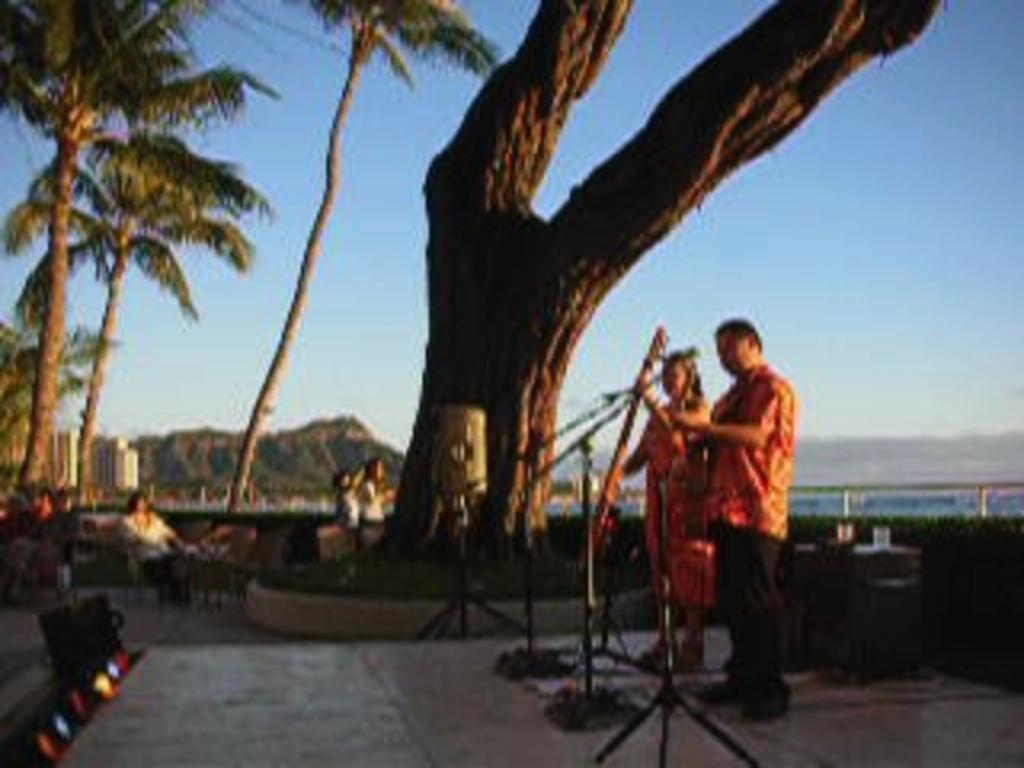How many people are standing on the right side of the image? There are two people standing people on the right side of the image. What can be seen near the standing people? There are mics placed on stands near the standing people. What is happening in the background of the image? In the background, there are people sitting, and trees, hills, and the sky are visible. Reasoning: Let's think step by step by step in order to produce the conversation. We start by identifying the main subjects and objects in the image based on the provided facts. We then formulate questions that focus on the location and characteristics of these subjects and objects, ensuring that each question can be answered definitively with the information given. We avoid yes/no questions and ensure that the language is simple and clear. Absurd Question/Answer: What is the opinion of the drain on the image? There is no drain present in the image, so it is not possible to determine its opinion. What grade does the person standing on the right side of the image have? There is no indication of the person's grade in the image, as it does not contain any information about their education or academic achievements. 